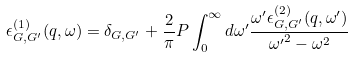Convert formula to latex. <formula><loc_0><loc_0><loc_500><loc_500>\epsilon ^ { ( 1 ) } _ { { G } , { G } ^ { \prime } } ( { q } , \omega ) = \delta _ { { G } , { G } ^ { \prime } } + \frac { 2 } { \pi } P \int _ { 0 } ^ { \infty } d \omega ^ { \prime } \frac { \omega ^ { \prime } \epsilon ^ { ( 2 ) } _ { { G } , { G } ^ { \prime } } ( { q } , \omega ^ { \prime } ) } { { \omega ^ { \prime } } ^ { 2 } - \omega ^ { 2 } }</formula> 